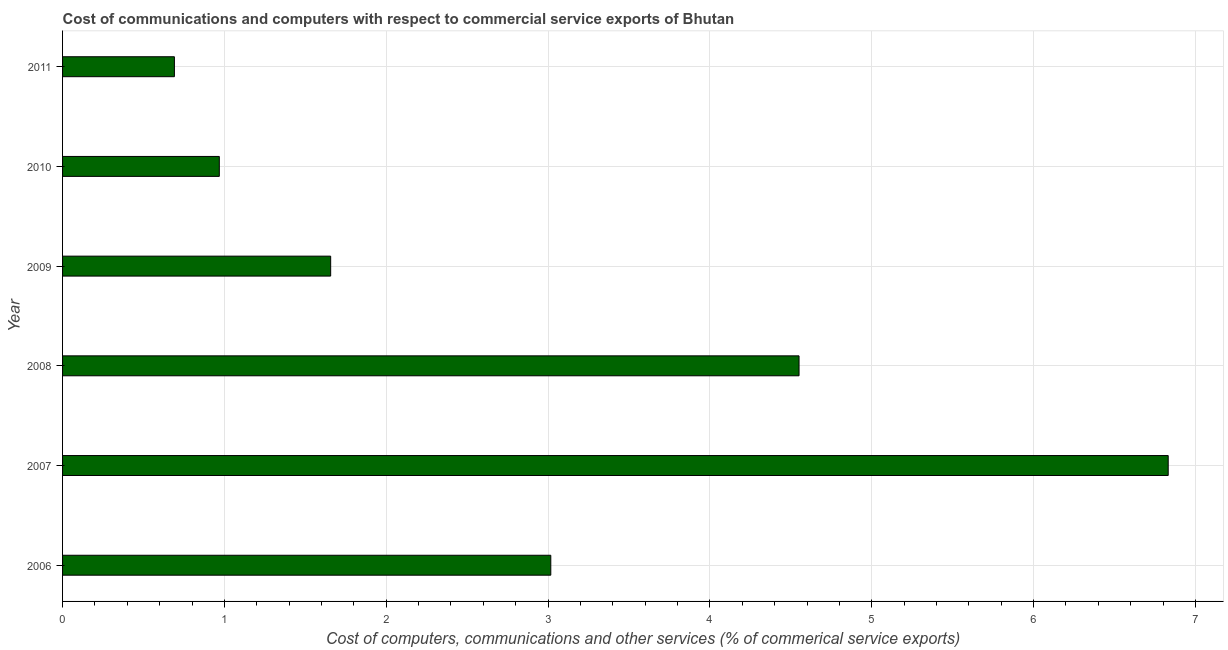What is the title of the graph?
Provide a short and direct response. Cost of communications and computers with respect to commercial service exports of Bhutan. What is the label or title of the X-axis?
Ensure brevity in your answer.  Cost of computers, communications and other services (% of commerical service exports). What is the cost of communications in 2009?
Ensure brevity in your answer.  1.66. Across all years, what is the maximum cost of communications?
Keep it short and to the point. 6.83. Across all years, what is the minimum  computer and other services?
Keep it short and to the point. 0.69. What is the sum of the cost of communications?
Your answer should be compact. 17.72. What is the difference between the  computer and other services in 2006 and 2008?
Offer a terse response. -1.53. What is the average  computer and other services per year?
Make the answer very short. 2.95. What is the median  computer and other services?
Offer a very short reply. 2.34. Do a majority of the years between 2008 and 2010 (inclusive) have cost of communications greater than 4.6 %?
Provide a succinct answer. No. What is the ratio of the cost of communications in 2007 to that in 2008?
Give a very brief answer. 1.5. Is the  computer and other services in 2006 less than that in 2009?
Offer a very short reply. No. Is the difference between the  computer and other services in 2006 and 2008 greater than the difference between any two years?
Offer a terse response. No. What is the difference between the highest and the second highest cost of communications?
Make the answer very short. 2.28. Is the sum of the  computer and other services in 2006 and 2007 greater than the maximum  computer and other services across all years?
Make the answer very short. Yes. What is the difference between the highest and the lowest  computer and other services?
Offer a terse response. 6.14. In how many years, is the cost of communications greater than the average cost of communications taken over all years?
Make the answer very short. 3. What is the difference between two consecutive major ticks on the X-axis?
Keep it short and to the point. 1. Are the values on the major ticks of X-axis written in scientific E-notation?
Keep it short and to the point. No. What is the Cost of computers, communications and other services (% of commerical service exports) of 2006?
Give a very brief answer. 3.02. What is the Cost of computers, communications and other services (% of commerical service exports) of 2007?
Provide a short and direct response. 6.83. What is the Cost of computers, communications and other services (% of commerical service exports) of 2008?
Provide a succinct answer. 4.55. What is the Cost of computers, communications and other services (% of commerical service exports) of 2009?
Provide a short and direct response. 1.66. What is the Cost of computers, communications and other services (% of commerical service exports) in 2010?
Provide a short and direct response. 0.97. What is the Cost of computers, communications and other services (% of commerical service exports) of 2011?
Offer a very short reply. 0.69. What is the difference between the Cost of computers, communications and other services (% of commerical service exports) in 2006 and 2007?
Offer a very short reply. -3.81. What is the difference between the Cost of computers, communications and other services (% of commerical service exports) in 2006 and 2008?
Offer a terse response. -1.53. What is the difference between the Cost of computers, communications and other services (% of commerical service exports) in 2006 and 2009?
Your answer should be very brief. 1.36. What is the difference between the Cost of computers, communications and other services (% of commerical service exports) in 2006 and 2010?
Your answer should be very brief. 2.05. What is the difference between the Cost of computers, communications and other services (% of commerical service exports) in 2006 and 2011?
Ensure brevity in your answer.  2.33. What is the difference between the Cost of computers, communications and other services (% of commerical service exports) in 2007 and 2008?
Make the answer very short. 2.28. What is the difference between the Cost of computers, communications and other services (% of commerical service exports) in 2007 and 2009?
Make the answer very short. 5.18. What is the difference between the Cost of computers, communications and other services (% of commerical service exports) in 2007 and 2010?
Ensure brevity in your answer.  5.86. What is the difference between the Cost of computers, communications and other services (% of commerical service exports) in 2007 and 2011?
Ensure brevity in your answer.  6.14. What is the difference between the Cost of computers, communications and other services (% of commerical service exports) in 2008 and 2009?
Make the answer very short. 2.89. What is the difference between the Cost of computers, communications and other services (% of commerical service exports) in 2008 and 2010?
Offer a terse response. 3.58. What is the difference between the Cost of computers, communications and other services (% of commerical service exports) in 2008 and 2011?
Provide a succinct answer. 3.86. What is the difference between the Cost of computers, communications and other services (% of commerical service exports) in 2009 and 2010?
Provide a succinct answer. 0.69. What is the difference between the Cost of computers, communications and other services (% of commerical service exports) in 2009 and 2011?
Offer a very short reply. 0.97. What is the difference between the Cost of computers, communications and other services (% of commerical service exports) in 2010 and 2011?
Make the answer very short. 0.28. What is the ratio of the Cost of computers, communications and other services (% of commerical service exports) in 2006 to that in 2007?
Provide a short and direct response. 0.44. What is the ratio of the Cost of computers, communications and other services (% of commerical service exports) in 2006 to that in 2008?
Offer a very short reply. 0.66. What is the ratio of the Cost of computers, communications and other services (% of commerical service exports) in 2006 to that in 2009?
Provide a short and direct response. 1.82. What is the ratio of the Cost of computers, communications and other services (% of commerical service exports) in 2006 to that in 2010?
Ensure brevity in your answer.  3.12. What is the ratio of the Cost of computers, communications and other services (% of commerical service exports) in 2006 to that in 2011?
Your answer should be compact. 4.37. What is the ratio of the Cost of computers, communications and other services (% of commerical service exports) in 2007 to that in 2008?
Keep it short and to the point. 1.5. What is the ratio of the Cost of computers, communications and other services (% of commerical service exports) in 2007 to that in 2009?
Offer a terse response. 4.12. What is the ratio of the Cost of computers, communications and other services (% of commerical service exports) in 2007 to that in 2010?
Ensure brevity in your answer.  7.05. What is the ratio of the Cost of computers, communications and other services (% of commerical service exports) in 2007 to that in 2011?
Your answer should be very brief. 9.89. What is the ratio of the Cost of computers, communications and other services (% of commerical service exports) in 2008 to that in 2009?
Provide a short and direct response. 2.75. What is the ratio of the Cost of computers, communications and other services (% of commerical service exports) in 2008 to that in 2010?
Your response must be concise. 4.7. What is the ratio of the Cost of computers, communications and other services (% of commerical service exports) in 2008 to that in 2011?
Provide a succinct answer. 6.58. What is the ratio of the Cost of computers, communications and other services (% of commerical service exports) in 2009 to that in 2010?
Your response must be concise. 1.71. What is the ratio of the Cost of computers, communications and other services (% of commerical service exports) in 2009 to that in 2011?
Your response must be concise. 2.4. What is the ratio of the Cost of computers, communications and other services (% of commerical service exports) in 2010 to that in 2011?
Your response must be concise. 1.4. 